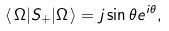<formula> <loc_0><loc_0><loc_500><loc_500>\langle \, \Omega | S _ { + } | \Omega \, \rangle = j \sin \theta e ^ { i \theta } ,</formula> 